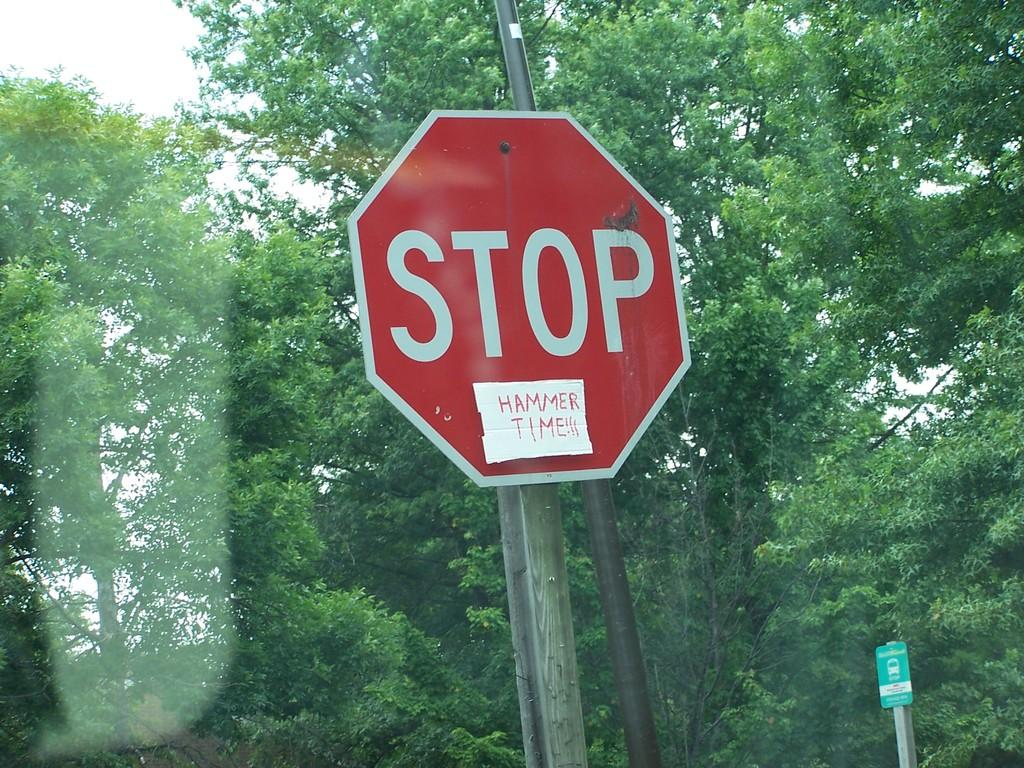<image>
Create a compact narrative representing the image presented. A stop sign with a sign that says Hammer Time taped to it. 